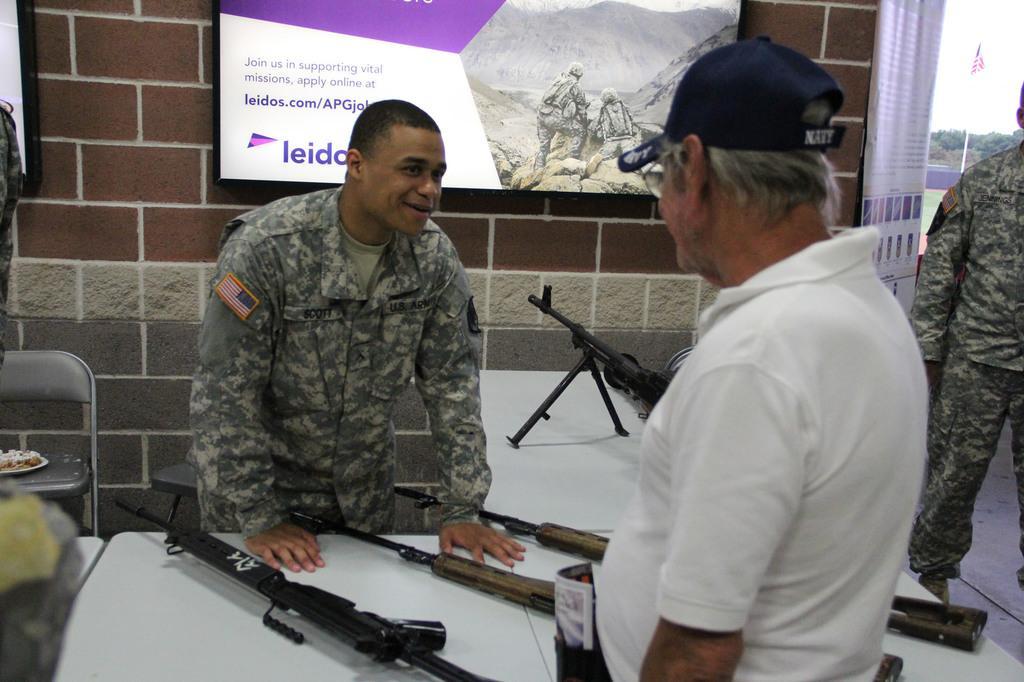Please provide a concise description of this image. In this image I can see a person wearing military uniform is standing in front of a white colored table and another person wearing white t shirt and cap is standing on the other side of the table. On the table I can see few guns which are black and brown in color. In the background I can see a television screen, the wall, a chair, a person standing, a flag, few trees and the sky. 